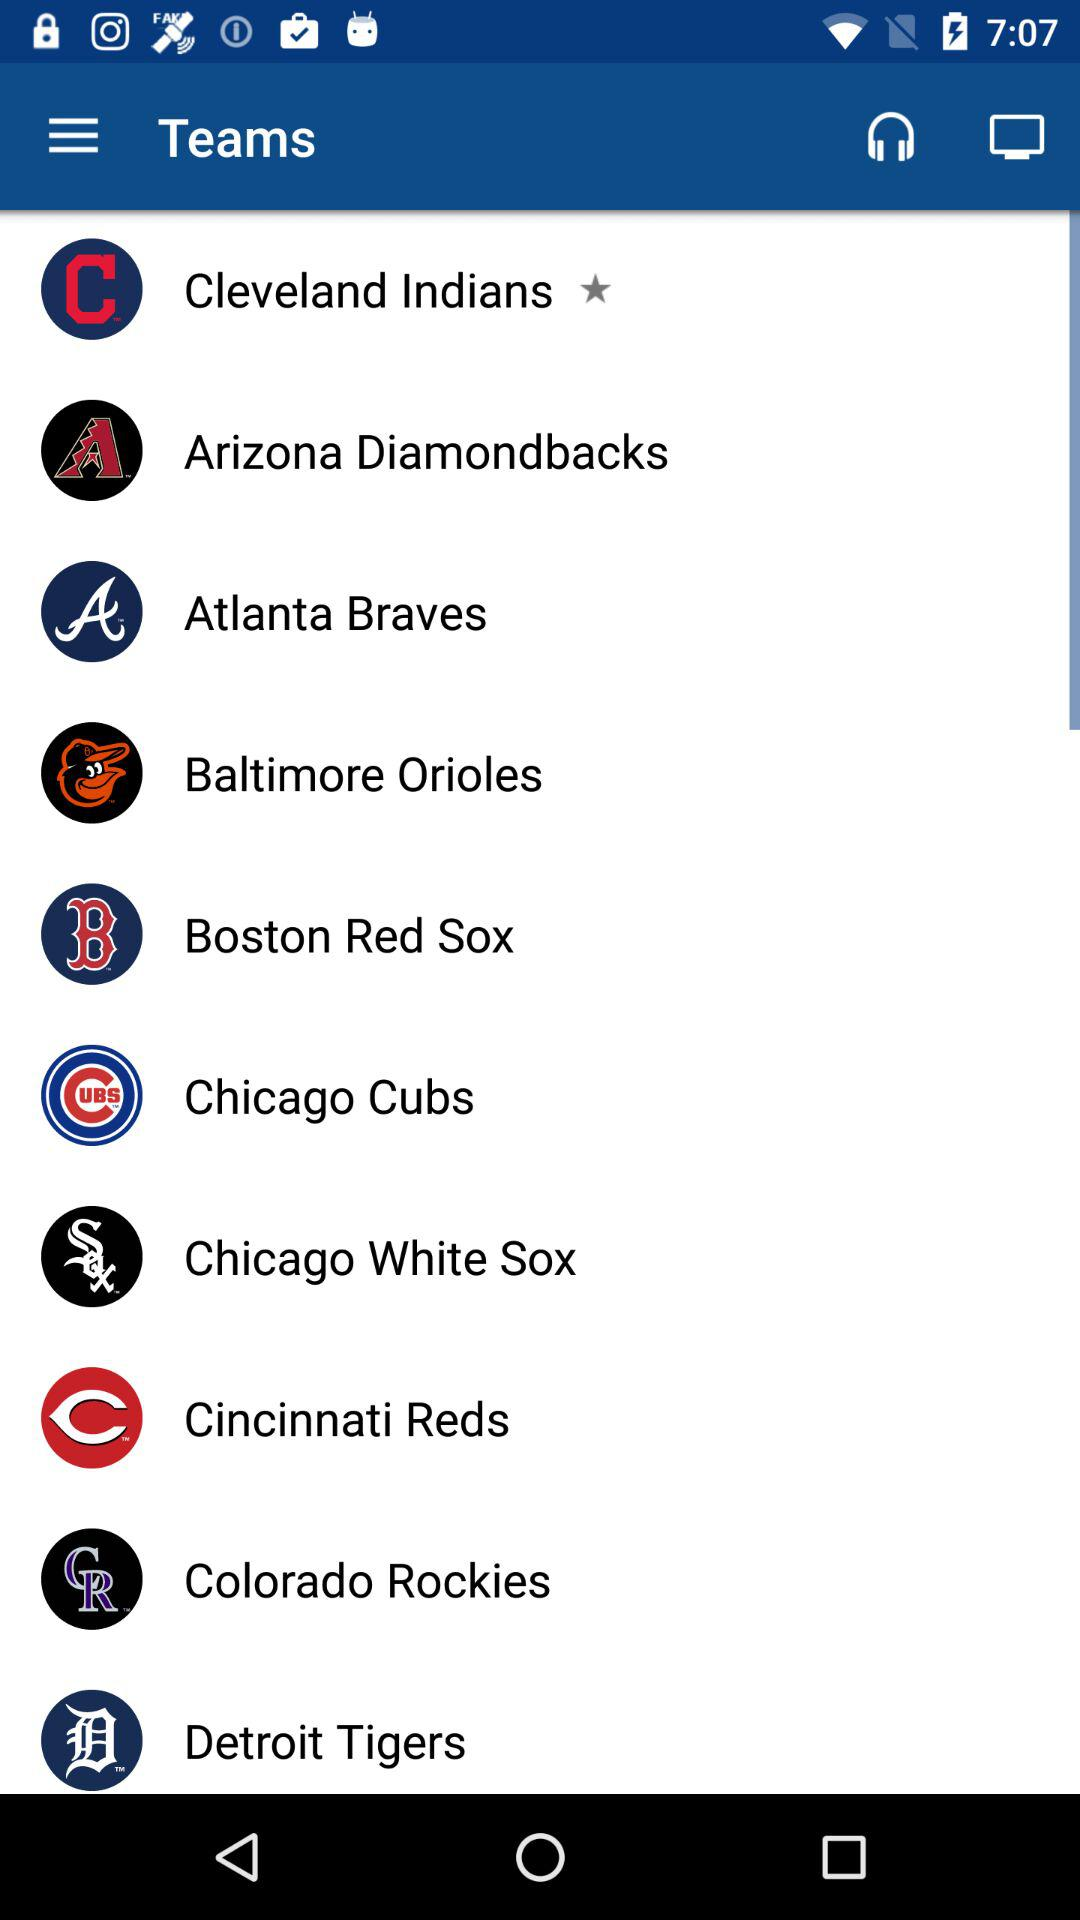How many teams have a logo that includes a color other than white?
Answer the question using a single word or phrase. 7 